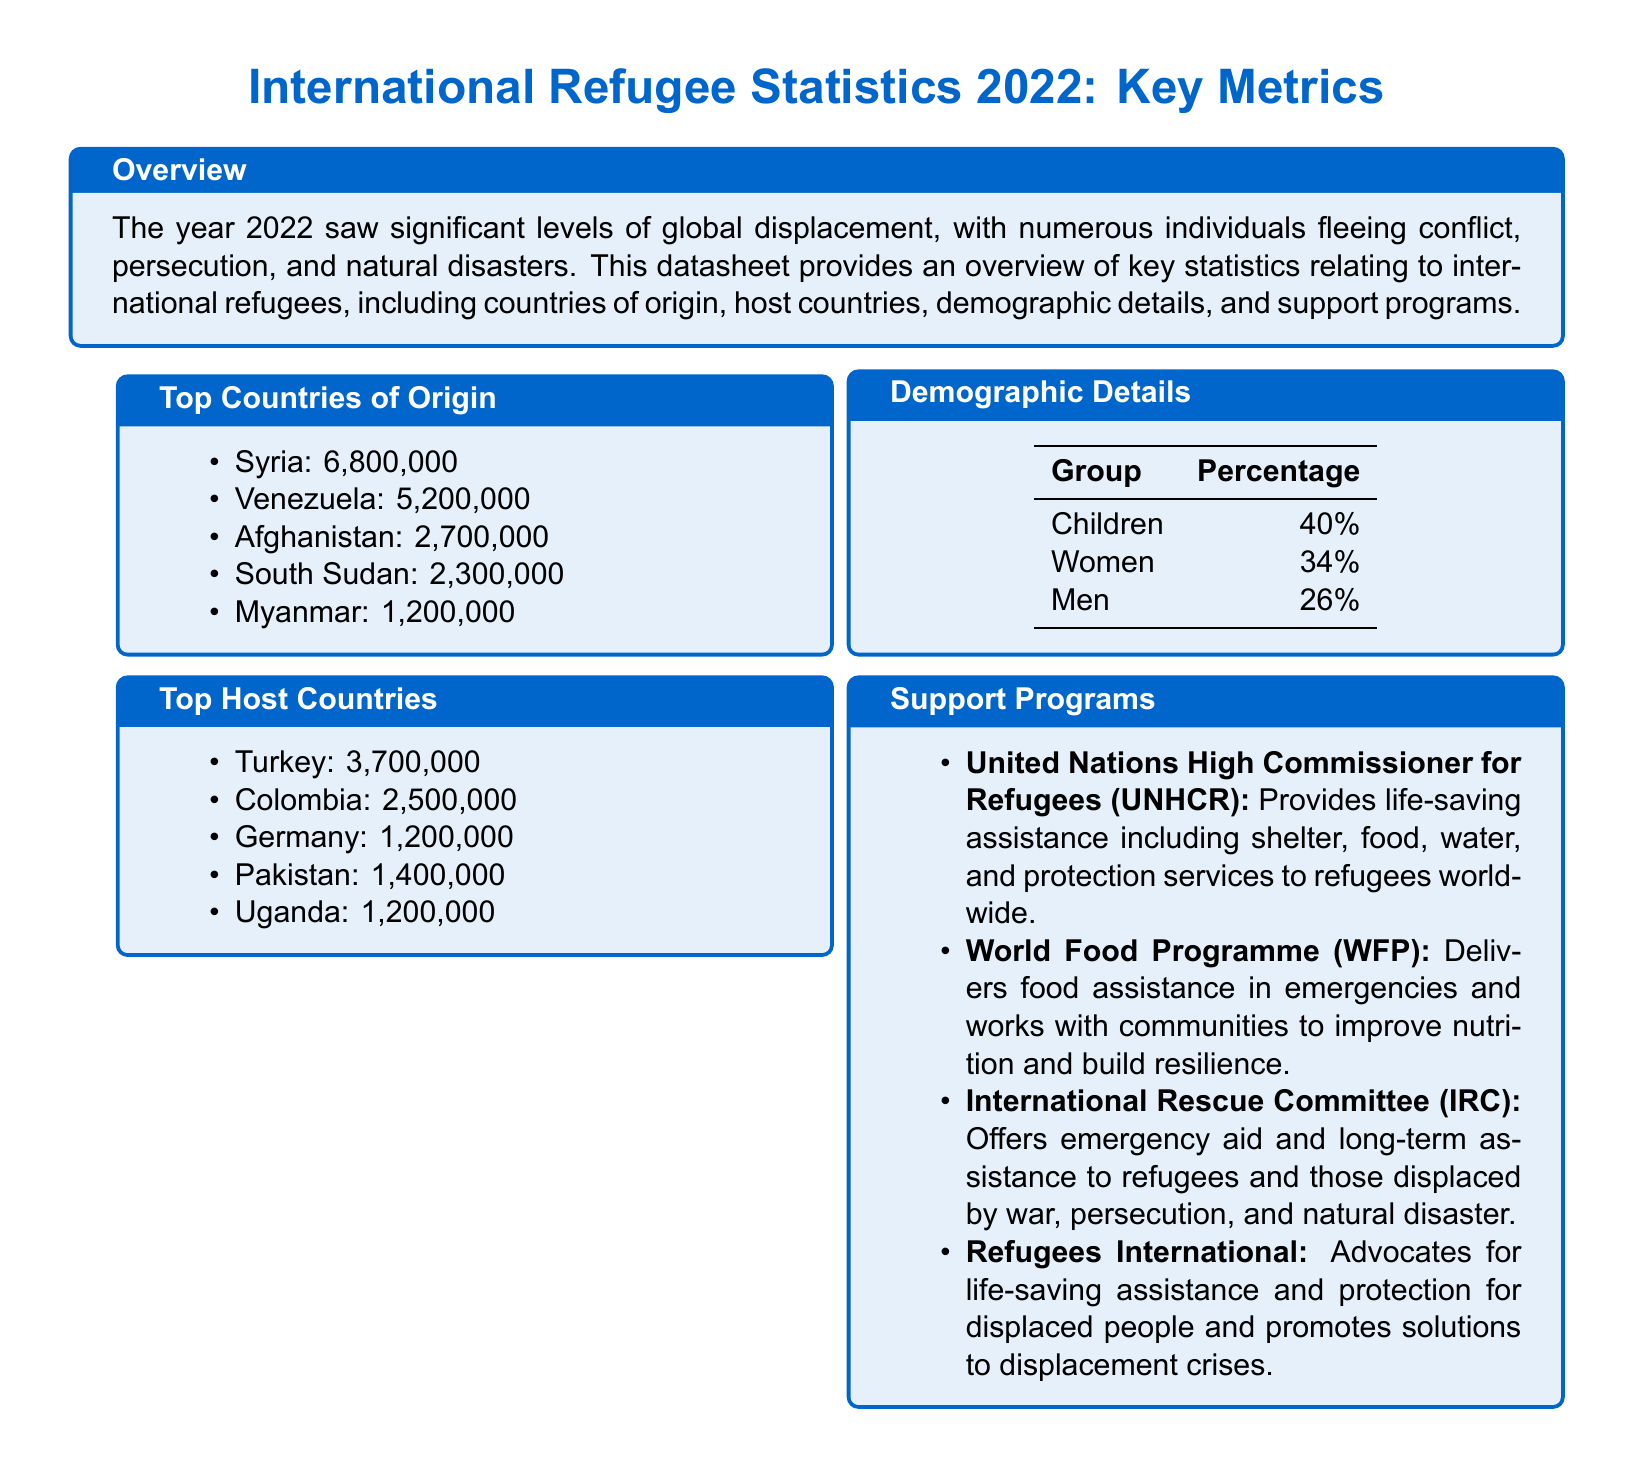What is the total number of refugees from Syria? The total number of refugees from Syria is listed in the document under Top Countries of Origin, stating that there are 6,800,000 refugees.
Answer: 6,800,000 Which country hosts the most refugees? The document indicates that Turkey hosts the most refugees, with a total of 3,700,000.
Answer: Turkey What percentage of refugees are children? The demographic details section provides that children represent 40% of the refugee population.
Answer: 40% How many refugees are from Afghanistan? The datasheet states that there are 2,700,000 refugees from Afghanistan in the list of Top Countries of Origin.
Answer: 2,700,000 Who provides food assistance in emergencies? The document mentions that the World Food Programme (WFP) delivers food assistance in emergencies.
Answer: World Food Programme Which demographic group has the lowest percentage among refugees? The demographic details show that men represent the lowest percentage, at 26%.
Answer: Men What is the total number of refugees from Venezuela? The datasheet lists 5,200,000 refugees from Venezuela in the Top Countries of Origin section.
Answer: 5,200,000 Which support program advocates for displaced people? The document highlights Refugees International as the support program that advocates for displaced people and promotes solutions to crises.
Answer: Refugees International What is the second most common country of origin for refugees? The list indicates that Venezuela is the second most common country of origin, with 5,200,000 refugees.
Answer: Venezuela How many refugees does Germany host? According to the document, Germany hosts 1,200,000 refugees as per the Top Host Countries section.
Answer: 1,200,000 